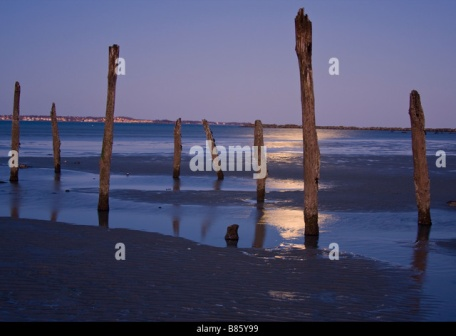Can you write a short poem inspired by this scene? In twilight's gentle, fading glow,
Seven sentinels stand row by row.
In whispered winds and waters low,
Their secrets washed in evening’s flow.
No footprints mar their flanked sand bed,
In silent vigil, tales unsaid.
Each wave that laps, each breath they shed,
Holds whispers of the twilight red. 